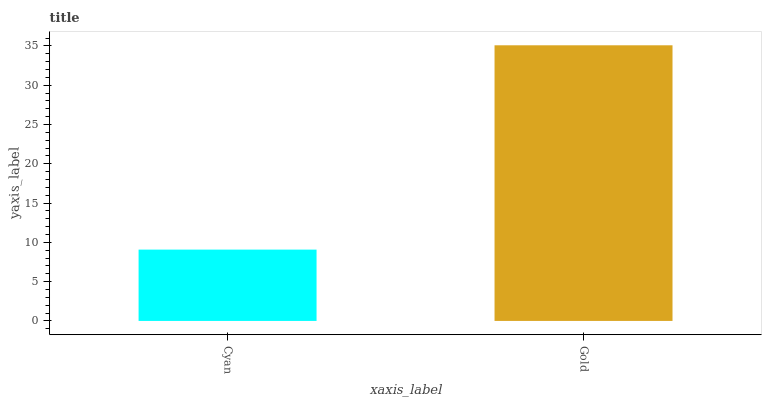Is Cyan the minimum?
Answer yes or no. Yes. Is Gold the maximum?
Answer yes or no. Yes. Is Gold the minimum?
Answer yes or no. No. Is Gold greater than Cyan?
Answer yes or no. Yes. Is Cyan less than Gold?
Answer yes or no. Yes. Is Cyan greater than Gold?
Answer yes or no. No. Is Gold less than Cyan?
Answer yes or no. No. Is Gold the high median?
Answer yes or no. Yes. Is Cyan the low median?
Answer yes or no. Yes. Is Cyan the high median?
Answer yes or no. No. Is Gold the low median?
Answer yes or no. No. 